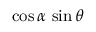<formula> <loc_0><loc_0><loc_500><loc_500>\cos \alpha \, \sin \theta</formula> 